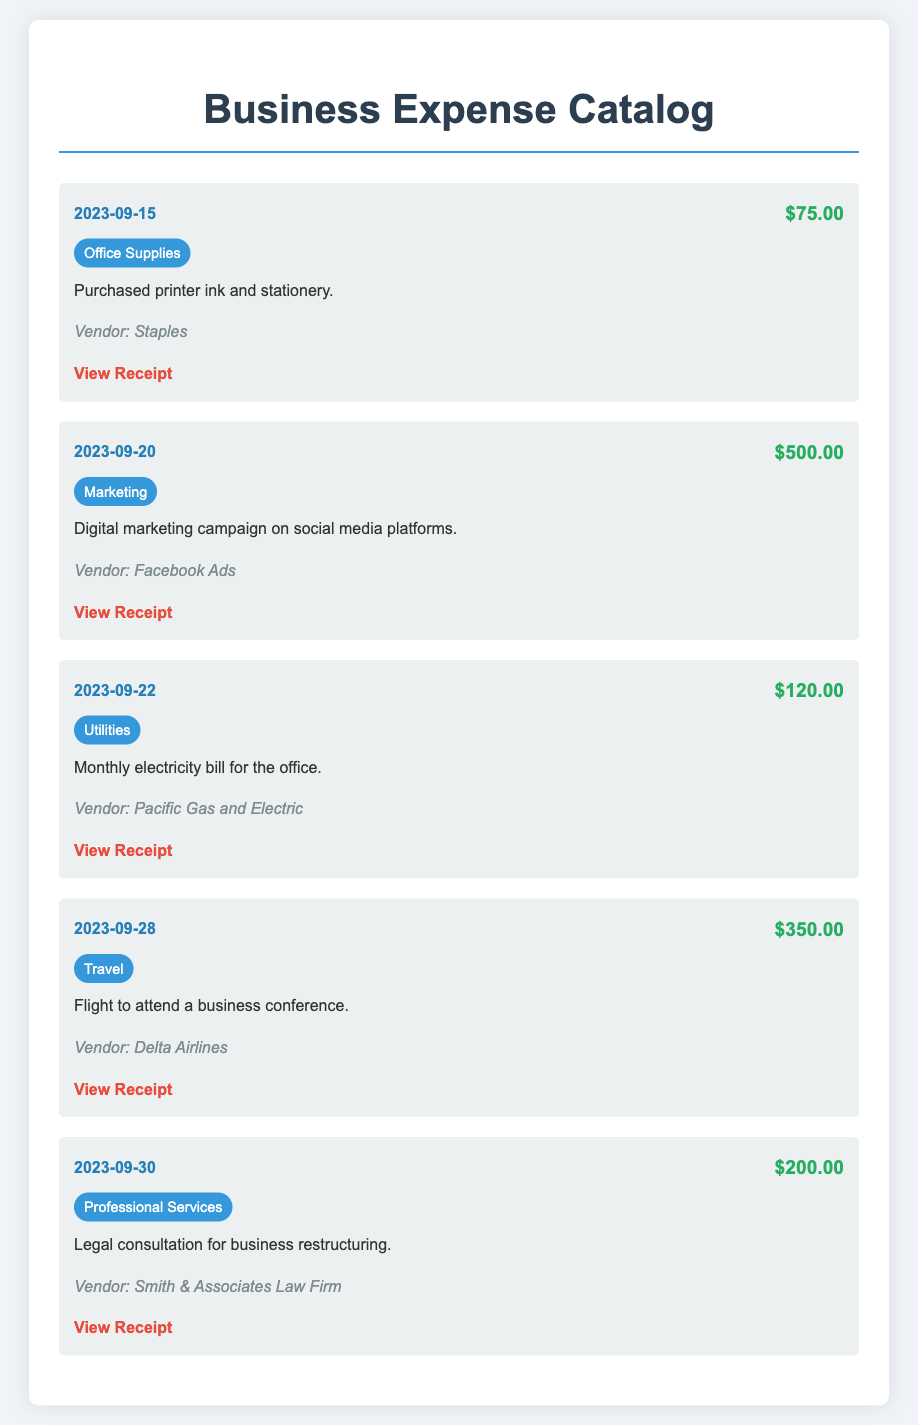What is the total expense for September 2023? The total expense is the sum of all expenses listed for that month, which is $75.00 + $500.00 + $120.00 + $350.00 + $200.00 = $1,345.00.
Answer: $1,345.00 What is the date of the highest expense? The highest expense is $500.00 on September 20, 2023.
Answer: September 20, 2023 Which vendor provided legal consultation services? The vendor for legal consultation is identified in the document as Smith & Associates Law Firm.
Answer: Smith & Associates Law Firm How much was spent on office supplies? The detail for office supplies indicates a purchase amount of $75.00.
Answer: $75.00 What category does the expense of $350.00 fall under? The expense of $350.00 is categorized under Travel as per the document.
Answer: Travel How many receipts are provided in the catalog? The catalog contains a total of 5 receipts attached for the different expenses listed.
Answer: 5 What was the description for the utilities expense? The utilities expense description states it was for the Monthly electricity bill for the office.
Answer: Monthly electricity bill for the office Which category has the second highest expense? The second highest expense, after Marketing, is in the Travel category, which is $350.00.
Answer: Travel 